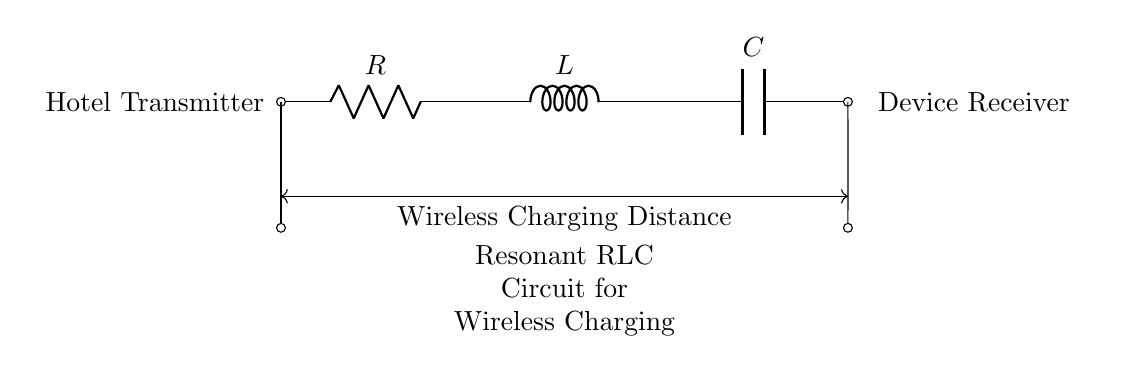What components are in this circuit? The circuit contains a resistor (R), an inductor (L), and a capacitor (C). These components are essential in forming a resonant RLC circuit.
Answer: Resistor, Inductor, Capacitor What does the arrow in the circuit indicate? The arrow indicates the direction of current flow in the circuit. It helps to identify how the electricity will travel through the components from the transmitter to the receiver.
Answer: Direction of current flow What is the primary function of the RLC circuit? The primary function of the RLC circuit is for wireless charging. This type of circuit allows for energy transfer via electromagnetic fields, which is essential in wireless power applications.
Answer: Wireless charging How does resistance affect the resonant frequency? Resistance can dampen the circuit, affecting its Q factor and thus altering how sharply the resonant frequency can be approached. Higher resistance usually leads to lower quality factor and broader resonance.
Answer: Damps circuit and alters Q factor What is the relationship between the inductor and capacitor in resonance? In resonance, the inductor and capacitor create a frequency where their reactance is equal and opposite, leading to maximum energy transfer. This equilibrium condition enables efficient wireless power transfer.
Answer: Equal and opposite reactance What should be considered for optimal charging distance? Optimal charging distance depends on the resonant frequency, the circuit's Q factor, and the efficiency of the coupling between the transmitter and receiver. Proper tuning of these factors is crucial for effective energy transfer.
Answer: Resonant frequency and Q factor How would you describe the arrangement of components in this circuit? The components are arranged in series, which is typical for resonant circuits. This series arrangement allows for a cohesive interaction between resistance, inductance, and capacitance, facilitating the overall operation of the circuit.
Answer: Series arrangement 